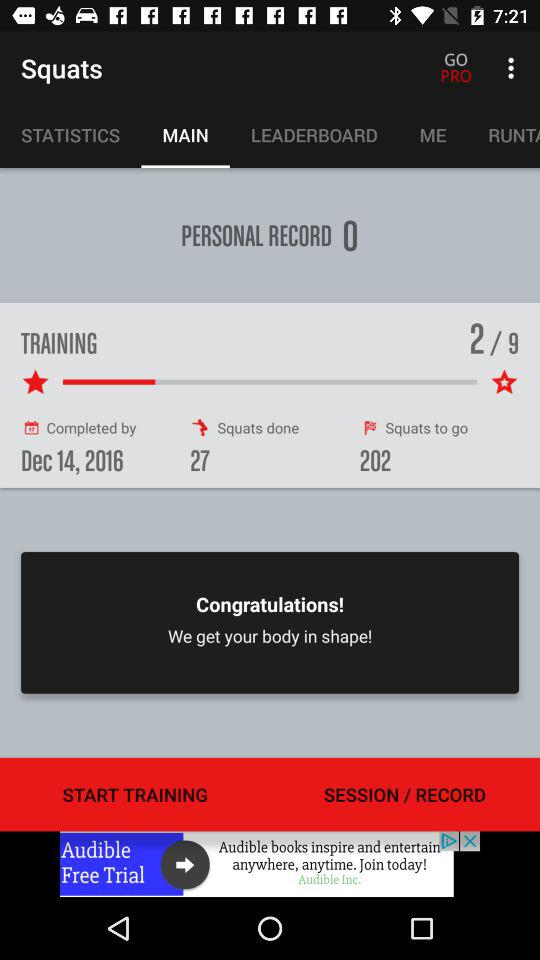How many parts are available for training? There are 9 parts available for training. 